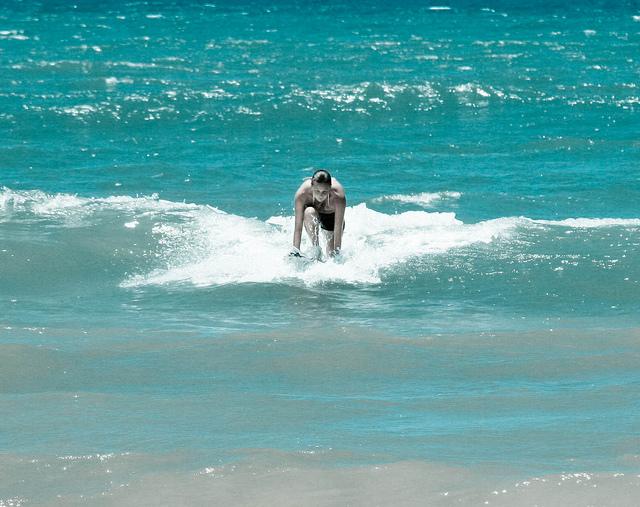What is the man doing?
Be succinct. Surfing. What condition is the water?
Be succinct. Clear. Will the man fall off the board?
Answer briefly. No. 